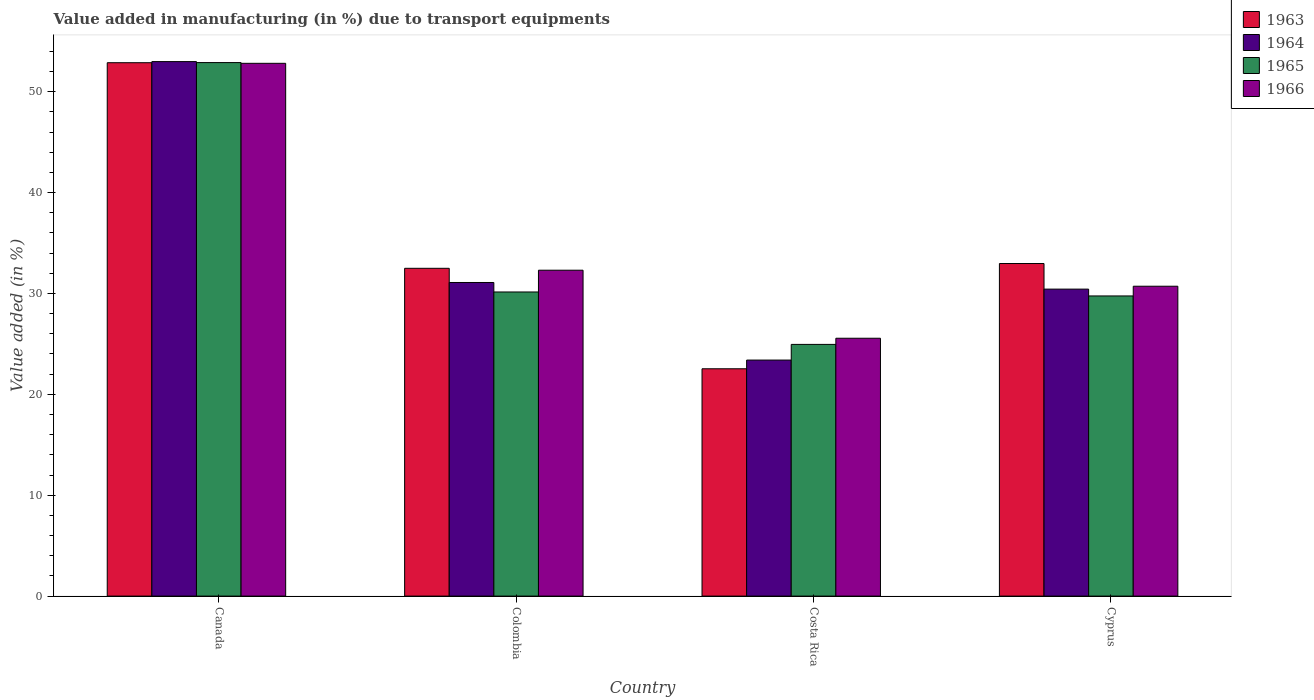How many different coloured bars are there?
Ensure brevity in your answer.  4. Are the number of bars per tick equal to the number of legend labels?
Keep it short and to the point. Yes. How many bars are there on the 3rd tick from the left?
Ensure brevity in your answer.  4. How many bars are there on the 4th tick from the right?
Provide a short and direct response. 4. What is the percentage of value added in manufacturing due to transport equipments in 1966 in Canada?
Offer a very short reply. 52.81. Across all countries, what is the maximum percentage of value added in manufacturing due to transport equipments in 1964?
Provide a succinct answer. 52.98. Across all countries, what is the minimum percentage of value added in manufacturing due to transport equipments in 1964?
Provide a succinct answer. 23.4. What is the total percentage of value added in manufacturing due to transport equipments in 1964 in the graph?
Give a very brief answer. 137.89. What is the difference between the percentage of value added in manufacturing due to transport equipments in 1965 in Colombia and that in Cyprus?
Keep it short and to the point. 0.39. What is the difference between the percentage of value added in manufacturing due to transport equipments in 1966 in Canada and the percentage of value added in manufacturing due to transport equipments in 1964 in Colombia?
Your answer should be very brief. 21.73. What is the average percentage of value added in manufacturing due to transport equipments in 1966 per country?
Your answer should be very brief. 35.35. What is the difference between the percentage of value added in manufacturing due to transport equipments of/in 1963 and percentage of value added in manufacturing due to transport equipments of/in 1964 in Costa Rica?
Your answer should be compact. -0.86. What is the ratio of the percentage of value added in manufacturing due to transport equipments in 1963 in Canada to that in Colombia?
Provide a short and direct response. 1.63. Is the percentage of value added in manufacturing due to transport equipments in 1966 in Canada less than that in Colombia?
Provide a succinct answer. No. What is the difference between the highest and the second highest percentage of value added in manufacturing due to transport equipments in 1966?
Offer a very short reply. -20.51. What is the difference between the highest and the lowest percentage of value added in manufacturing due to transport equipments in 1964?
Your answer should be very brief. 29.59. Is the sum of the percentage of value added in manufacturing due to transport equipments in 1966 in Canada and Cyprus greater than the maximum percentage of value added in manufacturing due to transport equipments in 1965 across all countries?
Offer a terse response. Yes. Is it the case that in every country, the sum of the percentage of value added in manufacturing due to transport equipments in 1966 and percentage of value added in manufacturing due to transport equipments in 1963 is greater than the sum of percentage of value added in manufacturing due to transport equipments in 1965 and percentage of value added in manufacturing due to transport equipments in 1964?
Your response must be concise. No. What does the 3rd bar from the left in Canada represents?
Your answer should be very brief. 1965. What does the 3rd bar from the right in Canada represents?
Make the answer very short. 1964. Is it the case that in every country, the sum of the percentage of value added in manufacturing due to transport equipments in 1964 and percentage of value added in manufacturing due to transport equipments in 1965 is greater than the percentage of value added in manufacturing due to transport equipments in 1963?
Ensure brevity in your answer.  Yes. How many bars are there?
Ensure brevity in your answer.  16. How many countries are there in the graph?
Provide a short and direct response. 4. What is the difference between two consecutive major ticks on the Y-axis?
Offer a very short reply. 10. Does the graph contain any zero values?
Offer a terse response. No. Does the graph contain grids?
Your response must be concise. No. How are the legend labels stacked?
Your answer should be very brief. Vertical. What is the title of the graph?
Provide a succinct answer. Value added in manufacturing (in %) due to transport equipments. Does "1987" appear as one of the legend labels in the graph?
Give a very brief answer. No. What is the label or title of the X-axis?
Your answer should be very brief. Country. What is the label or title of the Y-axis?
Give a very brief answer. Value added (in %). What is the Value added (in %) of 1963 in Canada?
Your answer should be very brief. 52.87. What is the Value added (in %) in 1964 in Canada?
Give a very brief answer. 52.98. What is the Value added (in %) of 1965 in Canada?
Make the answer very short. 52.89. What is the Value added (in %) of 1966 in Canada?
Provide a succinct answer. 52.81. What is the Value added (in %) in 1963 in Colombia?
Your answer should be compact. 32.49. What is the Value added (in %) in 1964 in Colombia?
Provide a short and direct response. 31.09. What is the Value added (in %) in 1965 in Colombia?
Ensure brevity in your answer.  30.15. What is the Value added (in %) in 1966 in Colombia?
Give a very brief answer. 32.3. What is the Value added (in %) in 1963 in Costa Rica?
Offer a terse response. 22.53. What is the Value added (in %) in 1964 in Costa Rica?
Your answer should be very brief. 23.4. What is the Value added (in %) in 1965 in Costa Rica?
Provide a succinct answer. 24.95. What is the Value added (in %) in 1966 in Costa Rica?
Provide a succinct answer. 25.56. What is the Value added (in %) in 1963 in Cyprus?
Ensure brevity in your answer.  32.97. What is the Value added (in %) in 1964 in Cyprus?
Your answer should be compact. 30.43. What is the Value added (in %) in 1965 in Cyprus?
Keep it short and to the point. 29.75. What is the Value added (in %) of 1966 in Cyprus?
Your answer should be compact. 30.72. Across all countries, what is the maximum Value added (in %) in 1963?
Offer a very short reply. 52.87. Across all countries, what is the maximum Value added (in %) in 1964?
Your answer should be compact. 52.98. Across all countries, what is the maximum Value added (in %) of 1965?
Your answer should be compact. 52.89. Across all countries, what is the maximum Value added (in %) in 1966?
Make the answer very short. 52.81. Across all countries, what is the minimum Value added (in %) in 1963?
Ensure brevity in your answer.  22.53. Across all countries, what is the minimum Value added (in %) in 1964?
Offer a terse response. 23.4. Across all countries, what is the minimum Value added (in %) in 1965?
Ensure brevity in your answer.  24.95. Across all countries, what is the minimum Value added (in %) of 1966?
Make the answer very short. 25.56. What is the total Value added (in %) of 1963 in the graph?
Ensure brevity in your answer.  140.87. What is the total Value added (in %) of 1964 in the graph?
Offer a terse response. 137.89. What is the total Value added (in %) of 1965 in the graph?
Your answer should be very brief. 137.73. What is the total Value added (in %) of 1966 in the graph?
Provide a succinct answer. 141.39. What is the difference between the Value added (in %) in 1963 in Canada and that in Colombia?
Offer a very short reply. 20.38. What is the difference between the Value added (in %) in 1964 in Canada and that in Colombia?
Keep it short and to the point. 21.9. What is the difference between the Value added (in %) of 1965 in Canada and that in Colombia?
Provide a succinct answer. 22.74. What is the difference between the Value added (in %) in 1966 in Canada and that in Colombia?
Your response must be concise. 20.51. What is the difference between the Value added (in %) of 1963 in Canada and that in Costa Rica?
Provide a short and direct response. 30.34. What is the difference between the Value added (in %) of 1964 in Canada and that in Costa Rica?
Make the answer very short. 29.59. What is the difference between the Value added (in %) in 1965 in Canada and that in Costa Rica?
Your answer should be very brief. 27.93. What is the difference between the Value added (in %) of 1966 in Canada and that in Costa Rica?
Provide a short and direct response. 27.25. What is the difference between the Value added (in %) of 1963 in Canada and that in Cyprus?
Your answer should be compact. 19.91. What is the difference between the Value added (in %) in 1964 in Canada and that in Cyprus?
Keep it short and to the point. 22.55. What is the difference between the Value added (in %) of 1965 in Canada and that in Cyprus?
Ensure brevity in your answer.  23.13. What is the difference between the Value added (in %) of 1966 in Canada and that in Cyprus?
Your answer should be very brief. 22.1. What is the difference between the Value added (in %) in 1963 in Colombia and that in Costa Rica?
Make the answer very short. 9.96. What is the difference between the Value added (in %) in 1964 in Colombia and that in Costa Rica?
Offer a very short reply. 7.69. What is the difference between the Value added (in %) of 1965 in Colombia and that in Costa Rica?
Provide a succinct answer. 5.2. What is the difference between the Value added (in %) in 1966 in Colombia and that in Costa Rica?
Offer a terse response. 6.74. What is the difference between the Value added (in %) in 1963 in Colombia and that in Cyprus?
Offer a terse response. -0.47. What is the difference between the Value added (in %) in 1964 in Colombia and that in Cyprus?
Ensure brevity in your answer.  0.66. What is the difference between the Value added (in %) of 1965 in Colombia and that in Cyprus?
Offer a very short reply. 0.39. What is the difference between the Value added (in %) of 1966 in Colombia and that in Cyprus?
Ensure brevity in your answer.  1.59. What is the difference between the Value added (in %) in 1963 in Costa Rica and that in Cyprus?
Make the answer very short. -10.43. What is the difference between the Value added (in %) in 1964 in Costa Rica and that in Cyprus?
Make the answer very short. -7.03. What is the difference between the Value added (in %) of 1965 in Costa Rica and that in Cyprus?
Your response must be concise. -4.8. What is the difference between the Value added (in %) of 1966 in Costa Rica and that in Cyprus?
Your answer should be very brief. -5.16. What is the difference between the Value added (in %) in 1963 in Canada and the Value added (in %) in 1964 in Colombia?
Offer a very short reply. 21.79. What is the difference between the Value added (in %) of 1963 in Canada and the Value added (in %) of 1965 in Colombia?
Provide a short and direct response. 22.73. What is the difference between the Value added (in %) of 1963 in Canada and the Value added (in %) of 1966 in Colombia?
Your answer should be very brief. 20.57. What is the difference between the Value added (in %) in 1964 in Canada and the Value added (in %) in 1965 in Colombia?
Give a very brief answer. 22.84. What is the difference between the Value added (in %) in 1964 in Canada and the Value added (in %) in 1966 in Colombia?
Keep it short and to the point. 20.68. What is the difference between the Value added (in %) in 1965 in Canada and the Value added (in %) in 1966 in Colombia?
Your answer should be compact. 20.58. What is the difference between the Value added (in %) in 1963 in Canada and the Value added (in %) in 1964 in Costa Rica?
Keep it short and to the point. 29.48. What is the difference between the Value added (in %) of 1963 in Canada and the Value added (in %) of 1965 in Costa Rica?
Give a very brief answer. 27.92. What is the difference between the Value added (in %) in 1963 in Canada and the Value added (in %) in 1966 in Costa Rica?
Your answer should be compact. 27.31. What is the difference between the Value added (in %) of 1964 in Canada and the Value added (in %) of 1965 in Costa Rica?
Your response must be concise. 28.03. What is the difference between the Value added (in %) in 1964 in Canada and the Value added (in %) in 1966 in Costa Rica?
Provide a succinct answer. 27.42. What is the difference between the Value added (in %) of 1965 in Canada and the Value added (in %) of 1966 in Costa Rica?
Make the answer very short. 27.33. What is the difference between the Value added (in %) in 1963 in Canada and the Value added (in %) in 1964 in Cyprus?
Provide a short and direct response. 22.44. What is the difference between the Value added (in %) of 1963 in Canada and the Value added (in %) of 1965 in Cyprus?
Your response must be concise. 23.12. What is the difference between the Value added (in %) in 1963 in Canada and the Value added (in %) in 1966 in Cyprus?
Keep it short and to the point. 22.16. What is the difference between the Value added (in %) in 1964 in Canada and the Value added (in %) in 1965 in Cyprus?
Provide a succinct answer. 23.23. What is the difference between the Value added (in %) in 1964 in Canada and the Value added (in %) in 1966 in Cyprus?
Offer a very short reply. 22.27. What is the difference between the Value added (in %) in 1965 in Canada and the Value added (in %) in 1966 in Cyprus?
Provide a short and direct response. 22.17. What is the difference between the Value added (in %) of 1963 in Colombia and the Value added (in %) of 1964 in Costa Rica?
Give a very brief answer. 9.1. What is the difference between the Value added (in %) in 1963 in Colombia and the Value added (in %) in 1965 in Costa Rica?
Ensure brevity in your answer.  7.54. What is the difference between the Value added (in %) of 1963 in Colombia and the Value added (in %) of 1966 in Costa Rica?
Keep it short and to the point. 6.93. What is the difference between the Value added (in %) in 1964 in Colombia and the Value added (in %) in 1965 in Costa Rica?
Provide a short and direct response. 6.14. What is the difference between the Value added (in %) in 1964 in Colombia and the Value added (in %) in 1966 in Costa Rica?
Offer a very short reply. 5.53. What is the difference between the Value added (in %) in 1965 in Colombia and the Value added (in %) in 1966 in Costa Rica?
Your answer should be very brief. 4.59. What is the difference between the Value added (in %) in 1963 in Colombia and the Value added (in %) in 1964 in Cyprus?
Keep it short and to the point. 2.06. What is the difference between the Value added (in %) of 1963 in Colombia and the Value added (in %) of 1965 in Cyprus?
Provide a succinct answer. 2.74. What is the difference between the Value added (in %) of 1963 in Colombia and the Value added (in %) of 1966 in Cyprus?
Ensure brevity in your answer.  1.78. What is the difference between the Value added (in %) of 1964 in Colombia and the Value added (in %) of 1965 in Cyprus?
Keep it short and to the point. 1.33. What is the difference between the Value added (in %) in 1964 in Colombia and the Value added (in %) in 1966 in Cyprus?
Your answer should be compact. 0.37. What is the difference between the Value added (in %) in 1965 in Colombia and the Value added (in %) in 1966 in Cyprus?
Offer a terse response. -0.57. What is the difference between the Value added (in %) in 1963 in Costa Rica and the Value added (in %) in 1964 in Cyprus?
Provide a short and direct response. -7.9. What is the difference between the Value added (in %) of 1963 in Costa Rica and the Value added (in %) of 1965 in Cyprus?
Provide a short and direct response. -7.22. What is the difference between the Value added (in %) in 1963 in Costa Rica and the Value added (in %) in 1966 in Cyprus?
Ensure brevity in your answer.  -8.18. What is the difference between the Value added (in %) of 1964 in Costa Rica and the Value added (in %) of 1965 in Cyprus?
Provide a short and direct response. -6.36. What is the difference between the Value added (in %) in 1964 in Costa Rica and the Value added (in %) in 1966 in Cyprus?
Keep it short and to the point. -7.32. What is the difference between the Value added (in %) in 1965 in Costa Rica and the Value added (in %) in 1966 in Cyprus?
Your answer should be compact. -5.77. What is the average Value added (in %) of 1963 per country?
Provide a short and direct response. 35.22. What is the average Value added (in %) of 1964 per country?
Your response must be concise. 34.47. What is the average Value added (in %) in 1965 per country?
Provide a succinct answer. 34.43. What is the average Value added (in %) of 1966 per country?
Give a very brief answer. 35.35. What is the difference between the Value added (in %) of 1963 and Value added (in %) of 1964 in Canada?
Make the answer very short. -0.11. What is the difference between the Value added (in %) of 1963 and Value added (in %) of 1965 in Canada?
Give a very brief answer. -0.01. What is the difference between the Value added (in %) in 1963 and Value added (in %) in 1966 in Canada?
Offer a very short reply. 0.06. What is the difference between the Value added (in %) in 1964 and Value added (in %) in 1965 in Canada?
Offer a very short reply. 0.1. What is the difference between the Value added (in %) in 1964 and Value added (in %) in 1966 in Canada?
Keep it short and to the point. 0.17. What is the difference between the Value added (in %) in 1965 and Value added (in %) in 1966 in Canada?
Your answer should be compact. 0.07. What is the difference between the Value added (in %) of 1963 and Value added (in %) of 1964 in Colombia?
Your answer should be compact. 1.41. What is the difference between the Value added (in %) in 1963 and Value added (in %) in 1965 in Colombia?
Offer a very short reply. 2.35. What is the difference between the Value added (in %) in 1963 and Value added (in %) in 1966 in Colombia?
Provide a short and direct response. 0.19. What is the difference between the Value added (in %) of 1964 and Value added (in %) of 1965 in Colombia?
Provide a succinct answer. 0.94. What is the difference between the Value added (in %) in 1964 and Value added (in %) in 1966 in Colombia?
Your answer should be compact. -1.22. What is the difference between the Value added (in %) in 1965 and Value added (in %) in 1966 in Colombia?
Ensure brevity in your answer.  -2.16. What is the difference between the Value added (in %) of 1963 and Value added (in %) of 1964 in Costa Rica?
Keep it short and to the point. -0.86. What is the difference between the Value added (in %) of 1963 and Value added (in %) of 1965 in Costa Rica?
Offer a terse response. -2.42. What is the difference between the Value added (in %) in 1963 and Value added (in %) in 1966 in Costa Rica?
Offer a very short reply. -3.03. What is the difference between the Value added (in %) in 1964 and Value added (in %) in 1965 in Costa Rica?
Your response must be concise. -1.55. What is the difference between the Value added (in %) of 1964 and Value added (in %) of 1966 in Costa Rica?
Give a very brief answer. -2.16. What is the difference between the Value added (in %) of 1965 and Value added (in %) of 1966 in Costa Rica?
Ensure brevity in your answer.  -0.61. What is the difference between the Value added (in %) in 1963 and Value added (in %) in 1964 in Cyprus?
Make the answer very short. 2.54. What is the difference between the Value added (in %) in 1963 and Value added (in %) in 1965 in Cyprus?
Offer a terse response. 3.21. What is the difference between the Value added (in %) in 1963 and Value added (in %) in 1966 in Cyprus?
Give a very brief answer. 2.25. What is the difference between the Value added (in %) of 1964 and Value added (in %) of 1965 in Cyprus?
Ensure brevity in your answer.  0.68. What is the difference between the Value added (in %) in 1964 and Value added (in %) in 1966 in Cyprus?
Give a very brief answer. -0.29. What is the difference between the Value added (in %) of 1965 and Value added (in %) of 1966 in Cyprus?
Your answer should be very brief. -0.96. What is the ratio of the Value added (in %) of 1963 in Canada to that in Colombia?
Keep it short and to the point. 1.63. What is the ratio of the Value added (in %) of 1964 in Canada to that in Colombia?
Provide a short and direct response. 1.7. What is the ratio of the Value added (in %) in 1965 in Canada to that in Colombia?
Your response must be concise. 1.75. What is the ratio of the Value added (in %) of 1966 in Canada to that in Colombia?
Give a very brief answer. 1.63. What is the ratio of the Value added (in %) in 1963 in Canada to that in Costa Rica?
Your answer should be compact. 2.35. What is the ratio of the Value added (in %) in 1964 in Canada to that in Costa Rica?
Give a very brief answer. 2.26. What is the ratio of the Value added (in %) in 1965 in Canada to that in Costa Rica?
Offer a very short reply. 2.12. What is the ratio of the Value added (in %) in 1966 in Canada to that in Costa Rica?
Make the answer very short. 2.07. What is the ratio of the Value added (in %) of 1963 in Canada to that in Cyprus?
Offer a terse response. 1.6. What is the ratio of the Value added (in %) of 1964 in Canada to that in Cyprus?
Provide a succinct answer. 1.74. What is the ratio of the Value added (in %) of 1965 in Canada to that in Cyprus?
Make the answer very short. 1.78. What is the ratio of the Value added (in %) in 1966 in Canada to that in Cyprus?
Your answer should be compact. 1.72. What is the ratio of the Value added (in %) of 1963 in Colombia to that in Costa Rica?
Offer a terse response. 1.44. What is the ratio of the Value added (in %) of 1964 in Colombia to that in Costa Rica?
Ensure brevity in your answer.  1.33. What is the ratio of the Value added (in %) in 1965 in Colombia to that in Costa Rica?
Your response must be concise. 1.21. What is the ratio of the Value added (in %) in 1966 in Colombia to that in Costa Rica?
Provide a short and direct response. 1.26. What is the ratio of the Value added (in %) of 1963 in Colombia to that in Cyprus?
Your answer should be compact. 0.99. What is the ratio of the Value added (in %) of 1964 in Colombia to that in Cyprus?
Keep it short and to the point. 1.02. What is the ratio of the Value added (in %) of 1965 in Colombia to that in Cyprus?
Provide a short and direct response. 1.01. What is the ratio of the Value added (in %) in 1966 in Colombia to that in Cyprus?
Offer a very short reply. 1.05. What is the ratio of the Value added (in %) of 1963 in Costa Rica to that in Cyprus?
Your answer should be compact. 0.68. What is the ratio of the Value added (in %) in 1964 in Costa Rica to that in Cyprus?
Offer a very short reply. 0.77. What is the ratio of the Value added (in %) in 1965 in Costa Rica to that in Cyprus?
Keep it short and to the point. 0.84. What is the ratio of the Value added (in %) in 1966 in Costa Rica to that in Cyprus?
Ensure brevity in your answer.  0.83. What is the difference between the highest and the second highest Value added (in %) in 1963?
Give a very brief answer. 19.91. What is the difference between the highest and the second highest Value added (in %) of 1964?
Your answer should be very brief. 21.9. What is the difference between the highest and the second highest Value added (in %) of 1965?
Provide a succinct answer. 22.74. What is the difference between the highest and the second highest Value added (in %) in 1966?
Ensure brevity in your answer.  20.51. What is the difference between the highest and the lowest Value added (in %) of 1963?
Offer a terse response. 30.34. What is the difference between the highest and the lowest Value added (in %) of 1964?
Give a very brief answer. 29.59. What is the difference between the highest and the lowest Value added (in %) of 1965?
Your answer should be very brief. 27.93. What is the difference between the highest and the lowest Value added (in %) of 1966?
Ensure brevity in your answer.  27.25. 